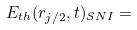Convert formula to latex. <formula><loc_0><loc_0><loc_500><loc_500>E _ { t h } ( r _ { j / 2 } , t ) _ { S N I } =</formula> 